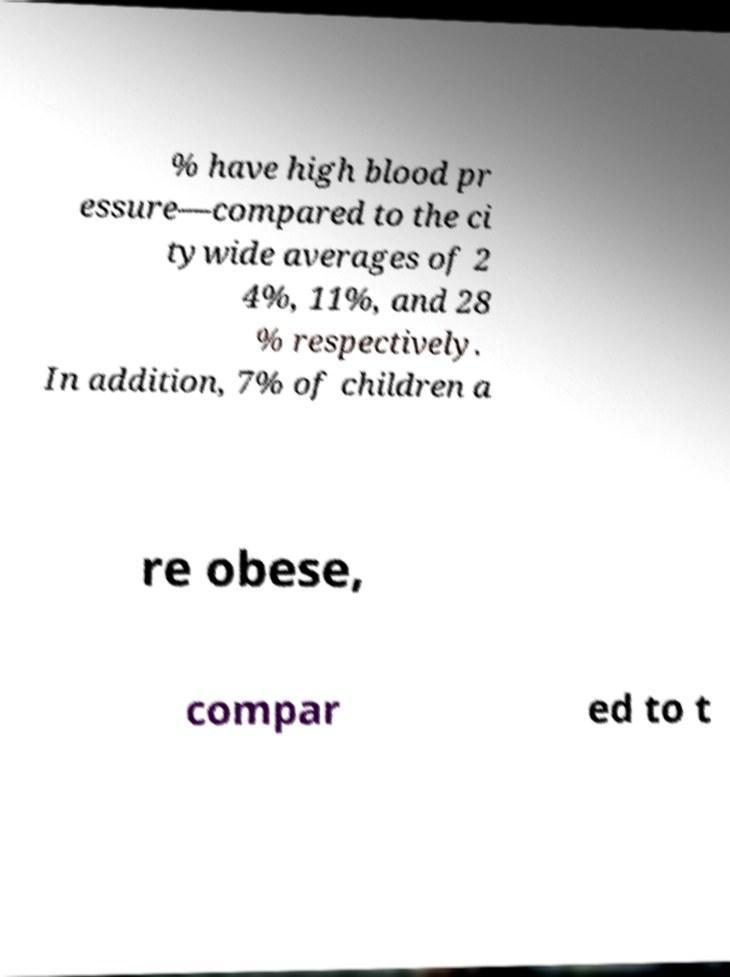Can you read and provide the text displayed in the image?This photo seems to have some interesting text. Can you extract and type it out for me? % have high blood pr essure—compared to the ci tywide averages of 2 4%, 11%, and 28 % respectively. In addition, 7% of children a re obese, compar ed to t 